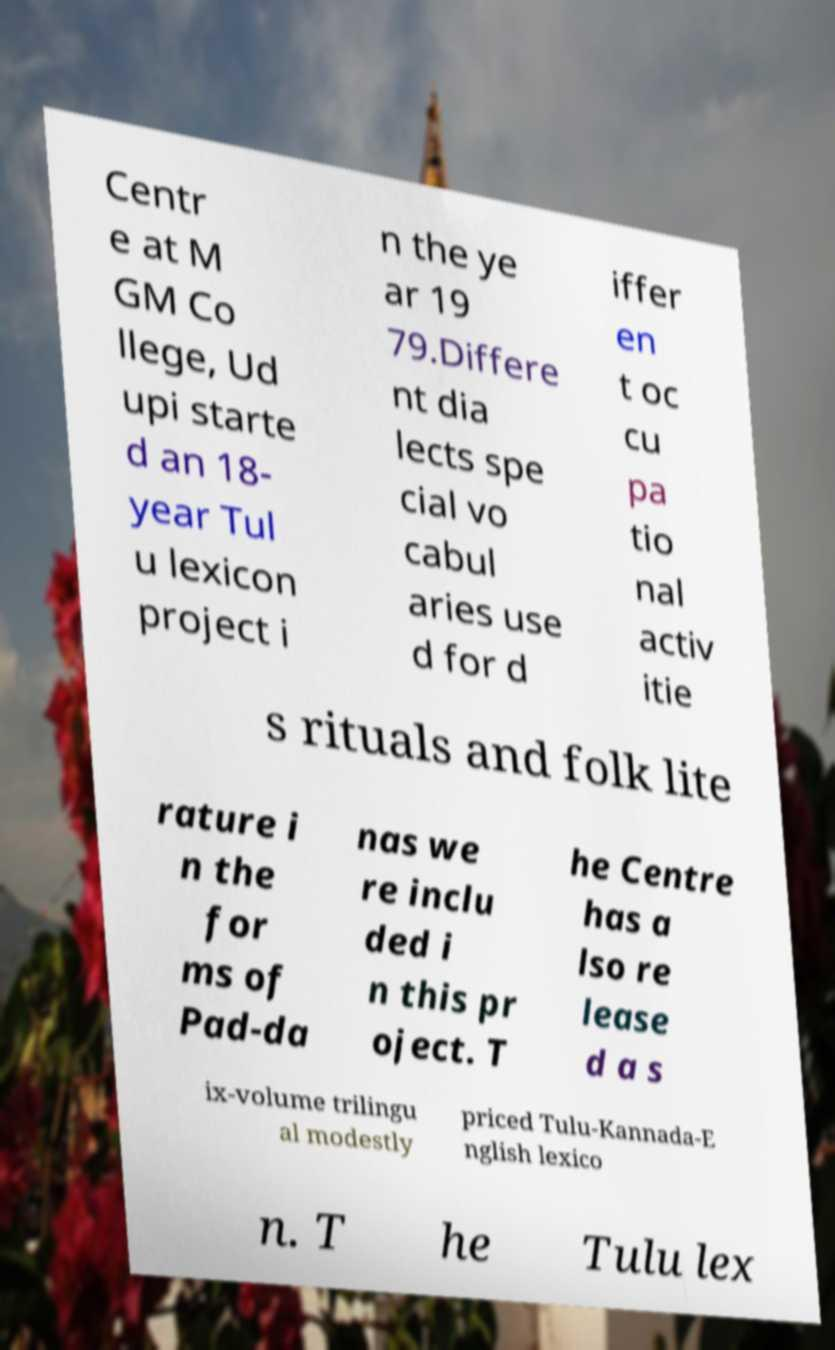What messages or text are displayed in this image? I need them in a readable, typed format. Centr e at M GM Co llege, Ud upi starte d an 18- year Tul u lexicon project i n the ye ar 19 79.Differe nt dia lects spe cial vo cabul aries use d for d iffer en t oc cu pa tio nal activ itie s rituals and folk lite rature i n the for ms of Pad-da nas we re inclu ded i n this pr oject. T he Centre has a lso re lease d a s ix-volume trilingu al modestly priced Tulu-Kannada-E nglish lexico n. T he Tulu lex 